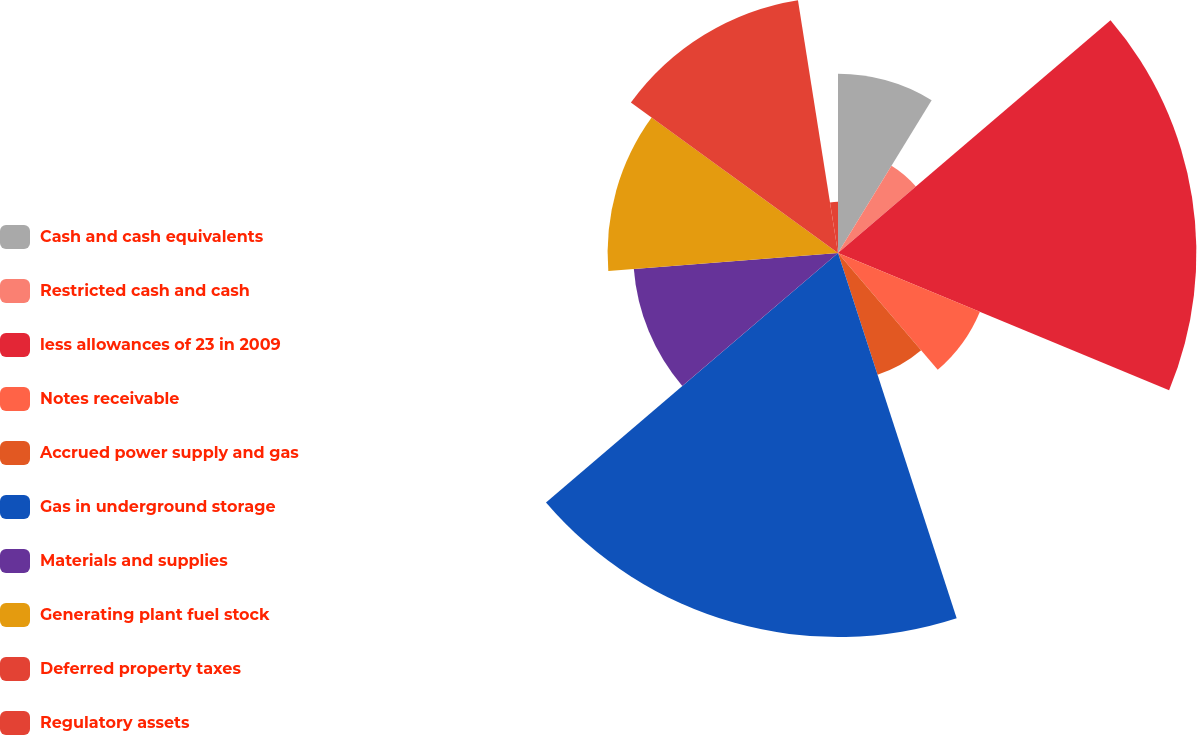Convert chart. <chart><loc_0><loc_0><loc_500><loc_500><pie_chart><fcel>Cash and cash equivalents<fcel>Restricted cash and cash<fcel>less allowances of 23 in 2009<fcel>Notes receivable<fcel>Accrued power supply and gas<fcel>Gas in underground storage<fcel>Materials and supplies<fcel>Generating plant fuel stock<fcel>Deferred property taxes<fcel>Regulatory assets<nl><fcel>8.75%<fcel>5.0%<fcel>17.5%<fcel>7.5%<fcel>6.25%<fcel>18.75%<fcel>10.0%<fcel>11.25%<fcel>12.5%<fcel>2.5%<nl></chart> 